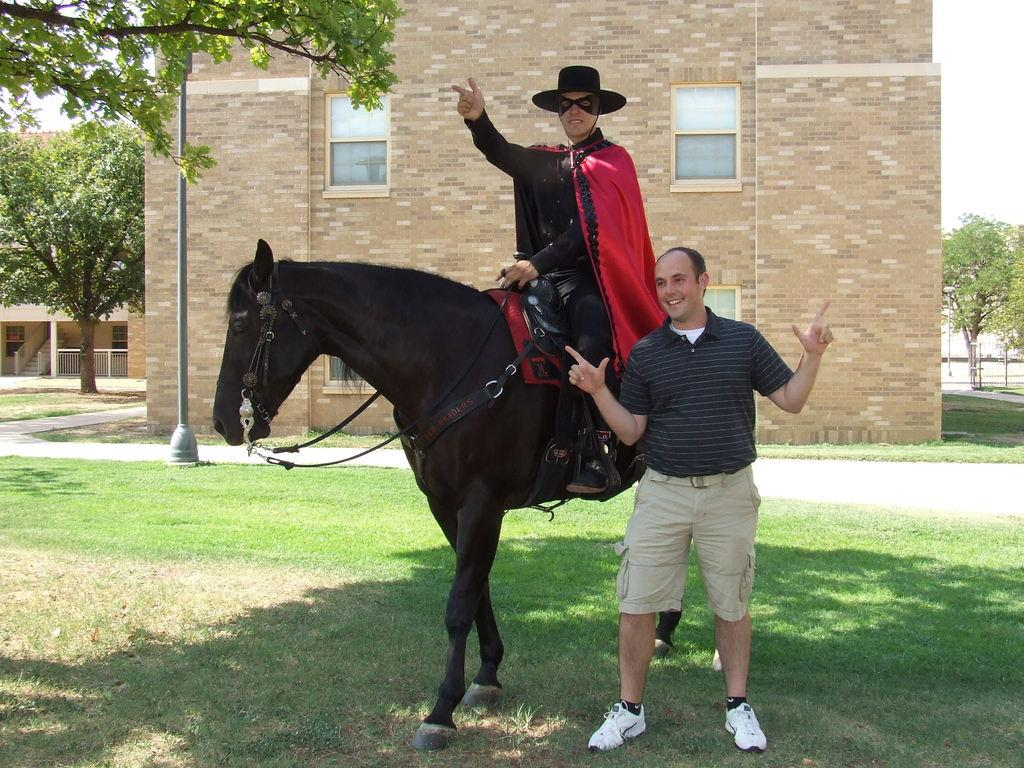What is the main subject of the image? There are two main subjects in the image: a man standing and posing, and another man sitting on a horse. What is the man on the horse doing? The man on the horse is sitting on the horse. What is the man on the horse wearing? The man on the horse is wearing a costume. What type of swing can be seen in the image? There is no swing present in the image. What type of war is depicted in the image? There is no war depicted in the image; it features two men, one standing and one sitting on a horse. 